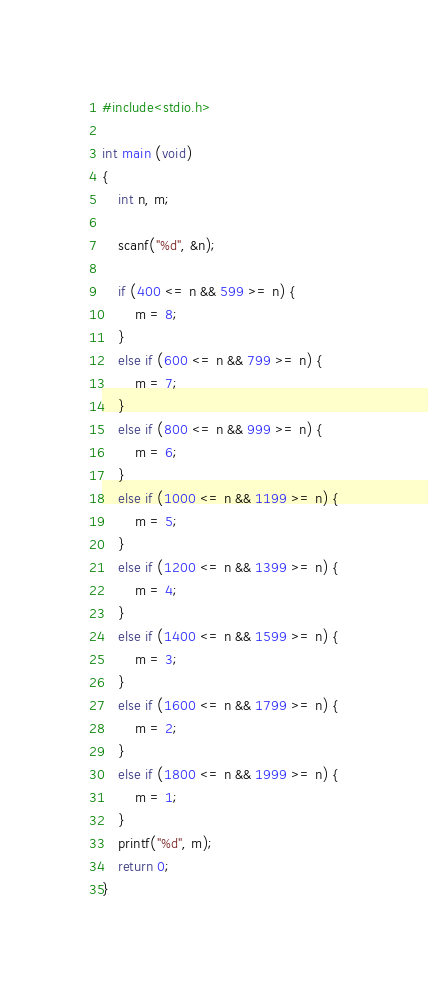Convert code to text. <code><loc_0><loc_0><loc_500><loc_500><_C_>#include<stdio.h>

int main (void)
{
    int n, m;

    scanf("%d", &n);

    if (400 <= n && 599 >= n) {
        m = 8;
    }
    else if (600 <= n && 799 >= n) {
        m = 7;
    }
    else if (800 <= n && 999 >= n) {
        m = 6;
    }
    else if (1000 <= n && 1199 >= n) {
        m = 5;
    }
    else if (1200 <= n && 1399 >= n) {
        m = 4;
    }
    else if (1400 <= n && 1599 >= n) {
        m = 3;
    }
    else if (1600 <= n && 1799 >= n) {
        m = 2;
    }
    else if (1800 <= n && 1999 >= n) {
        m = 1;
    }
    printf("%d", m);
    return 0;
}</code> 